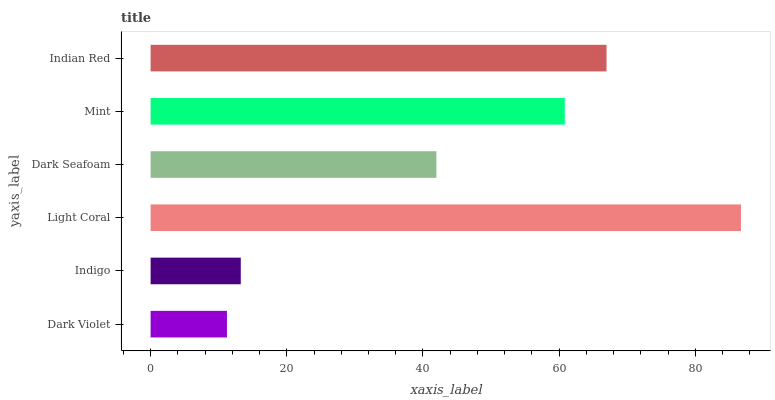Is Dark Violet the minimum?
Answer yes or no. Yes. Is Light Coral the maximum?
Answer yes or no. Yes. Is Indigo the minimum?
Answer yes or no. No. Is Indigo the maximum?
Answer yes or no. No. Is Indigo greater than Dark Violet?
Answer yes or no. Yes. Is Dark Violet less than Indigo?
Answer yes or no. Yes. Is Dark Violet greater than Indigo?
Answer yes or no. No. Is Indigo less than Dark Violet?
Answer yes or no. No. Is Mint the high median?
Answer yes or no. Yes. Is Dark Seafoam the low median?
Answer yes or no. Yes. Is Indigo the high median?
Answer yes or no. No. Is Mint the low median?
Answer yes or no. No. 